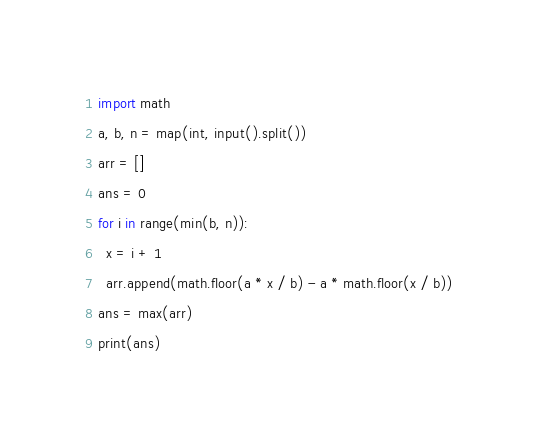Convert code to text. <code><loc_0><loc_0><loc_500><loc_500><_Python_>import math
a, b, n = map(int, input().split())
arr = []
ans = 0
for i in range(min(b, n)):
  x = i + 1
  arr.append(math.floor(a * x / b) - a * math.floor(x / b))
ans = max(arr)
print(ans)</code> 